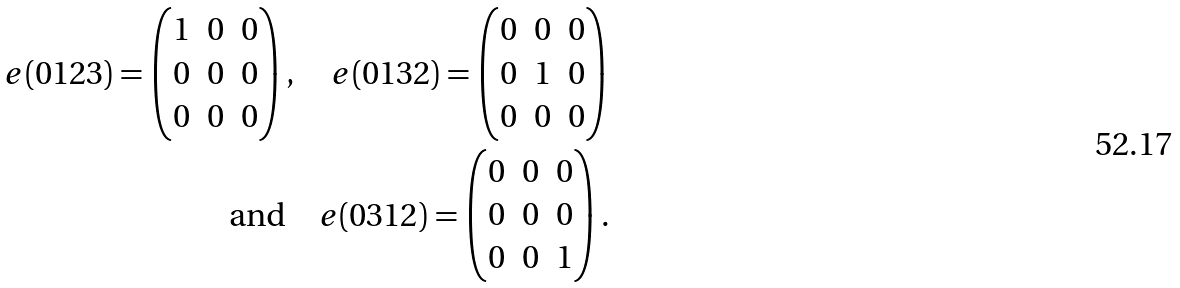Convert formula to latex. <formula><loc_0><loc_0><loc_500><loc_500>e ( 0 1 2 3 ) = \begin{pmatrix} 1 & 0 & 0 \\ 0 & 0 & 0 \\ 0 & 0 & 0 \end{pmatrix} , \quad e ( 0 1 3 2 ) = \begin{pmatrix} 0 & 0 & 0 \\ 0 & 1 & 0 \\ 0 & 0 & 0 \end{pmatrix} \\ \text {and} \quad e ( 0 3 1 2 ) = \begin{pmatrix} 0 & 0 & 0 \\ 0 & 0 & 0 \\ 0 & 0 & 1 \end{pmatrix} .</formula> 